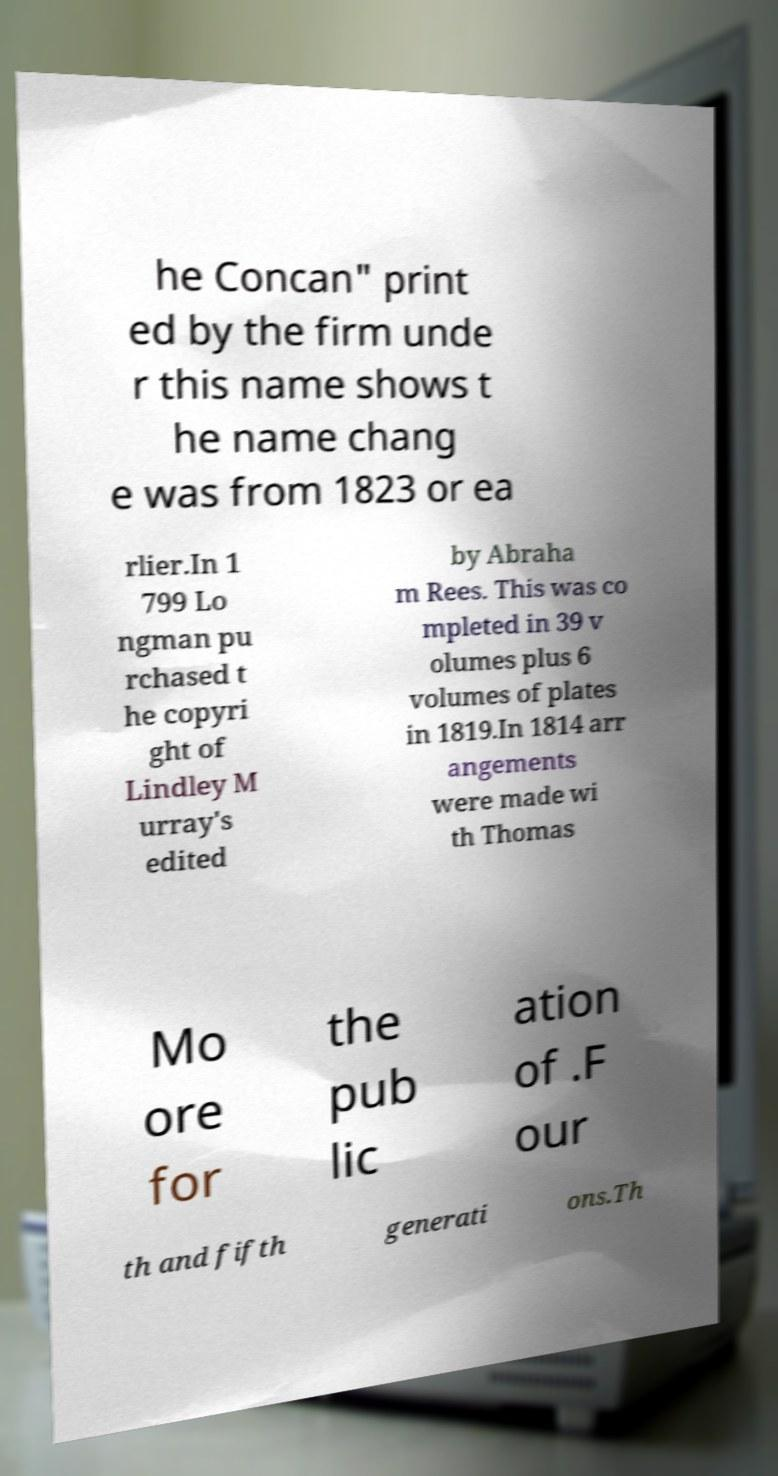Please identify and transcribe the text found in this image. he Concan" print ed by the firm unde r this name shows t he name chang e was from 1823 or ea rlier.In 1 799 Lo ngman pu rchased t he copyri ght of Lindley M urray's edited by Abraha m Rees. This was co mpleted in 39 v olumes plus 6 volumes of plates in 1819.In 1814 arr angements were made wi th Thomas Mo ore for the pub lic ation of .F our th and fifth generati ons.Th 